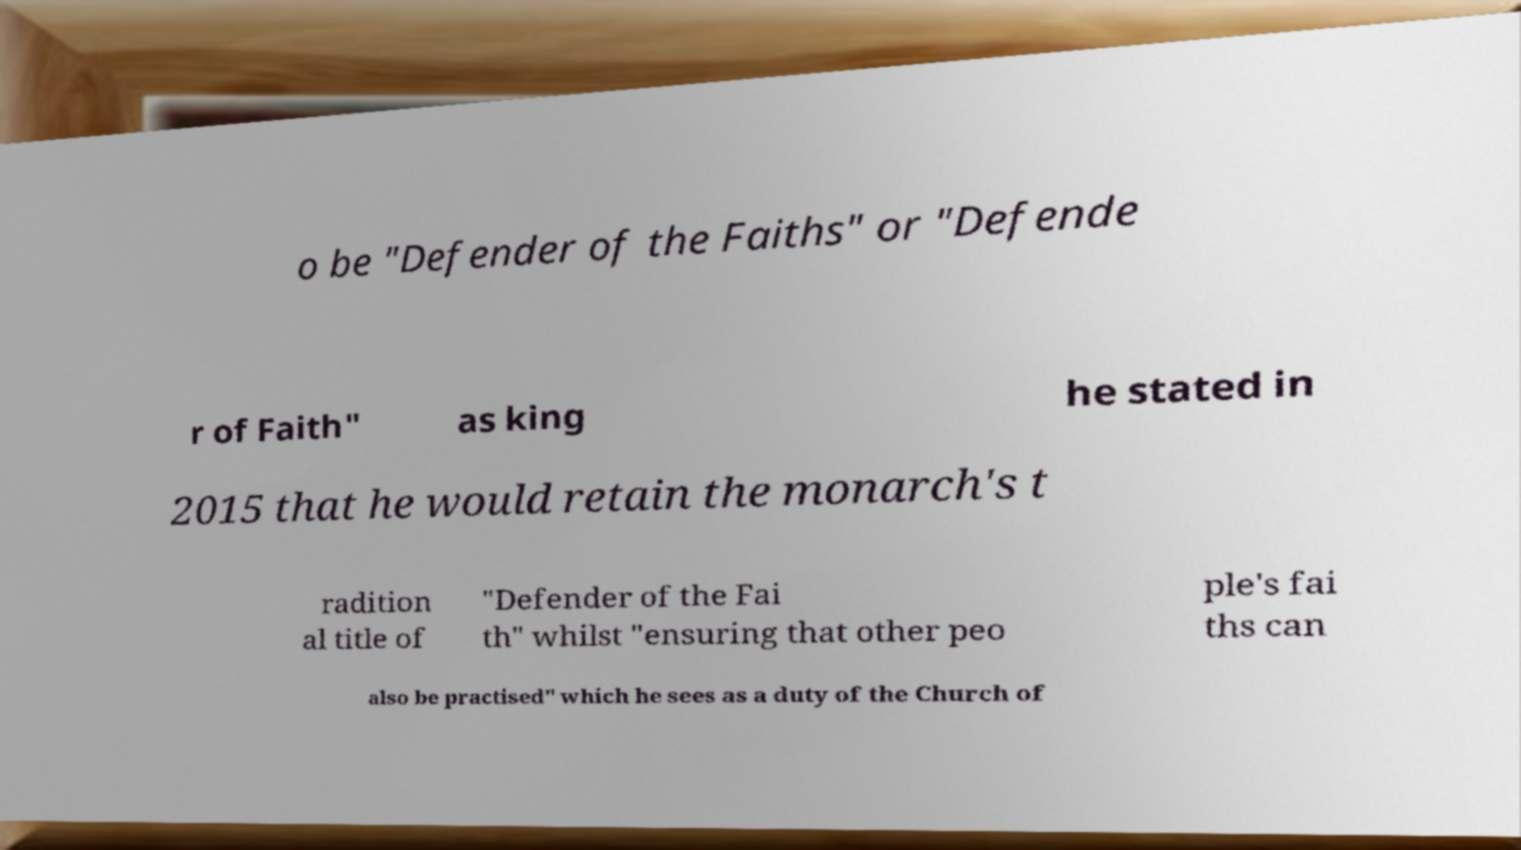Can you accurately transcribe the text from the provided image for me? o be "Defender of the Faiths" or "Defende r of Faith" as king he stated in 2015 that he would retain the monarch's t radition al title of "Defender of the Fai th" whilst "ensuring that other peo ple's fai ths can also be practised" which he sees as a duty of the Church of 